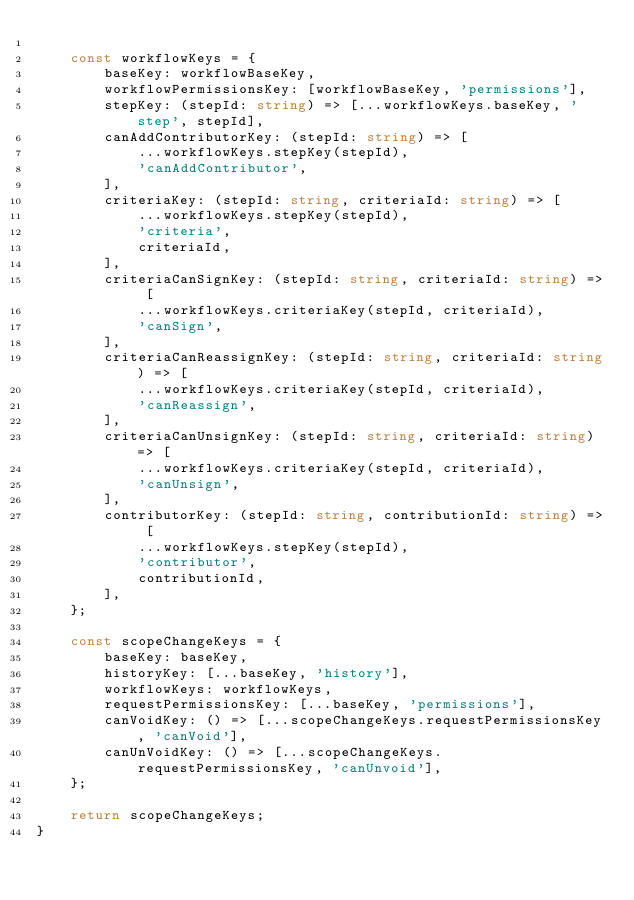Convert code to text. <code><loc_0><loc_0><loc_500><loc_500><_TypeScript_>
    const workflowKeys = {
        baseKey: workflowBaseKey,
        workflowPermissionsKey: [workflowBaseKey, 'permissions'],
        stepKey: (stepId: string) => [...workflowKeys.baseKey, 'step', stepId],
        canAddContributorKey: (stepId: string) => [
            ...workflowKeys.stepKey(stepId),
            'canAddContributor',
        ],
        criteriaKey: (stepId: string, criteriaId: string) => [
            ...workflowKeys.stepKey(stepId),
            'criteria',
            criteriaId,
        ],
        criteriaCanSignKey: (stepId: string, criteriaId: string) => [
            ...workflowKeys.criteriaKey(stepId, criteriaId),
            'canSign',
        ],
        criteriaCanReassignKey: (stepId: string, criteriaId: string) => [
            ...workflowKeys.criteriaKey(stepId, criteriaId),
            'canReassign',
        ],
        criteriaCanUnsignKey: (stepId: string, criteriaId: string) => [
            ...workflowKeys.criteriaKey(stepId, criteriaId),
            'canUnsign',
        ],
        contributorKey: (stepId: string, contributionId: string) => [
            ...workflowKeys.stepKey(stepId),
            'contributor',
            contributionId,
        ],
    };

    const scopeChangeKeys = {
        baseKey: baseKey,
        historyKey: [...baseKey, 'history'],
        workflowKeys: workflowKeys,
        requestPermissionsKey: [...baseKey, 'permissions'],
        canVoidKey: () => [...scopeChangeKeys.requestPermissionsKey, 'canVoid'],
        canUnVoidKey: () => [...scopeChangeKeys.requestPermissionsKey, 'canUnvoid'],
    };

    return scopeChangeKeys;
}
</code> 